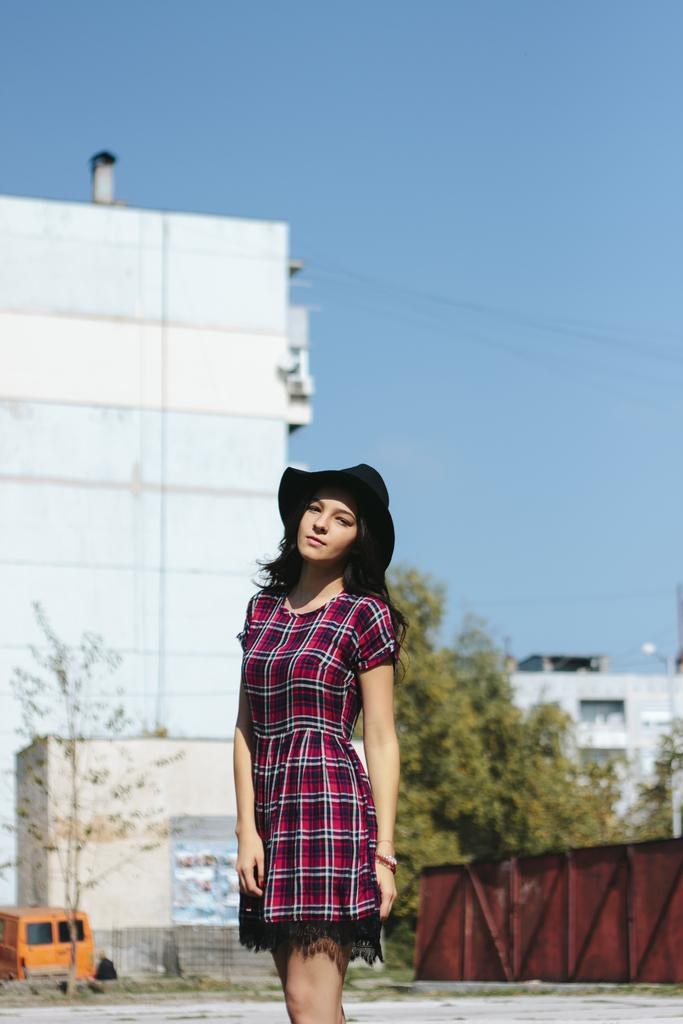Who is present in the image? There is a woman in the image. What is the woman wearing on her head? The woman is wearing a hat. What can be seen in the distance behind the woman? Trees, vehicles, and buildings are visible in the background of the image. What type of poison is the woman holding in the image? There is no poison present in the image; the woman is wearing a hat and there are no objects in her hands. 